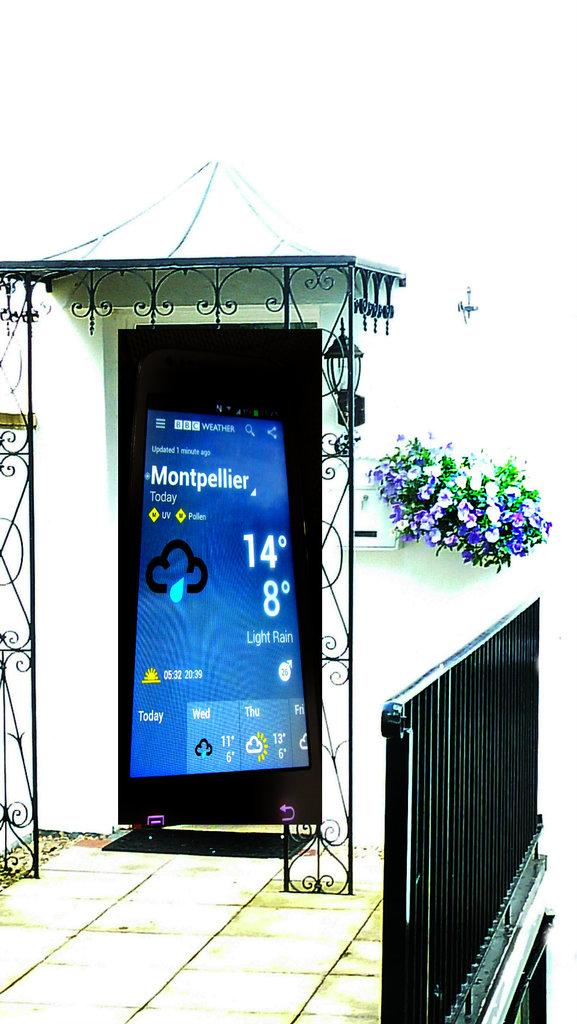<image>
Write a terse but informative summary of the picture. A screenshot of Montpellier's current weather is superimposed over the front door of a house. 